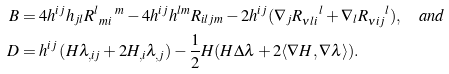Convert formula to latex. <formula><loc_0><loc_0><loc_500><loc_500>B & = 4 h ^ { i j } h _ { j l } R _ { \ m i \ } ^ { l \quad m } - 4 h ^ { i j } h ^ { l m } R _ { i l j m } - 2 h ^ { i j } ( \nabla _ { j } R _ { \nu l i } ^ { \quad l } + \nabla _ { l } R _ { \nu i j } ^ { \quad l } ) , \quad a n d \\ D & = h ^ { i j } \left ( H \lambda _ { , i j } + 2 H _ { , i } \lambda _ { , j } \right ) - \frac { 1 } { 2 } H ( H \Delta \lambda + 2 \langle \nabla H , \nabla \lambda \rangle ) .</formula> 